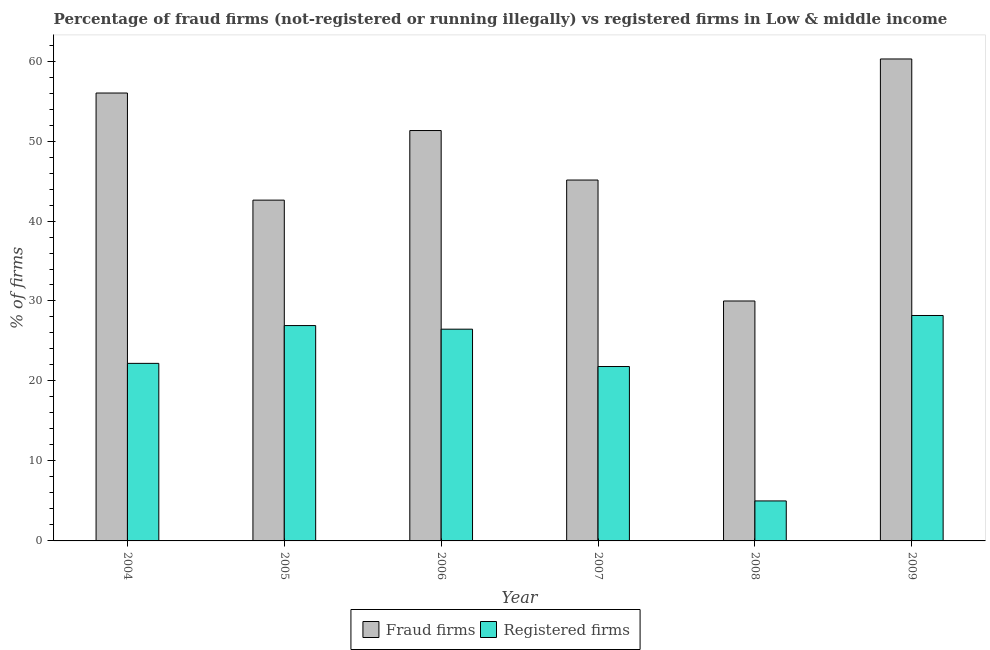How many groups of bars are there?
Provide a short and direct response. 6. How many bars are there on the 2nd tick from the left?
Provide a short and direct response. 2. How many bars are there on the 2nd tick from the right?
Keep it short and to the point. 2. What is the label of the 6th group of bars from the left?
Offer a terse response. 2009. What is the percentage of registered firms in 2005?
Offer a very short reply. 26.93. Across all years, what is the maximum percentage of registered firms?
Your answer should be compact. 28.19. Across all years, what is the minimum percentage of fraud firms?
Keep it short and to the point. 30. What is the total percentage of fraud firms in the graph?
Provide a short and direct response. 285.31. What is the difference between the percentage of registered firms in 2005 and that in 2009?
Ensure brevity in your answer.  -1.26. What is the difference between the percentage of registered firms in 2008 and the percentage of fraud firms in 2004?
Keep it short and to the point. -17.2. What is the average percentage of fraud firms per year?
Your answer should be very brief. 47.55. In the year 2005, what is the difference between the percentage of fraud firms and percentage of registered firms?
Make the answer very short. 0. What is the ratio of the percentage of registered firms in 2004 to that in 2005?
Provide a succinct answer. 0.82. Is the difference between the percentage of fraud firms in 2005 and 2009 greater than the difference between the percentage of registered firms in 2005 and 2009?
Make the answer very short. No. What is the difference between the highest and the second highest percentage of registered firms?
Offer a terse response. 1.26. What is the difference between the highest and the lowest percentage of fraud firms?
Your response must be concise. 30.26. What does the 1st bar from the left in 2008 represents?
Your answer should be very brief. Fraud firms. What does the 2nd bar from the right in 2008 represents?
Your answer should be very brief. Fraud firms. How many bars are there?
Make the answer very short. 12. Are all the bars in the graph horizontal?
Offer a very short reply. No. How many years are there in the graph?
Give a very brief answer. 6. What is the difference between two consecutive major ticks on the Y-axis?
Make the answer very short. 10. Are the values on the major ticks of Y-axis written in scientific E-notation?
Offer a terse response. No. Does the graph contain any zero values?
Keep it short and to the point. No. Where does the legend appear in the graph?
Your response must be concise. Bottom center. What is the title of the graph?
Ensure brevity in your answer.  Percentage of fraud firms (not-registered or running illegally) vs registered firms in Low & middle income. What is the label or title of the Y-axis?
Offer a terse response. % of firms. What is the % of firms of Fraud firms in 2004?
Keep it short and to the point. 56.01. What is the % of firms of Fraud firms in 2005?
Give a very brief answer. 42.61. What is the % of firms of Registered firms in 2005?
Ensure brevity in your answer.  26.93. What is the % of firms of Fraud firms in 2006?
Make the answer very short. 51.31. What is the % of firms of Registered firms in 2006?
Keep it short and to the point. 26.48. What is the % of firms of Fraud firms in 2007?
Ensure brevity in your answer.  45.12. What is the % of firms of Registered firms in 2007?
Your answer should be compact. 21.81. What is the % of firms in Fraud firms in 2008?
Provide a short and direct response. 30. What is the % of firms in Fraud firms in 2009?
Provide a short and direct response. 60.26. What is the % of firms in Registered firms in 2009?
Provide a succinct answer. 28.19. Across all years, what is the maximum % of firms of Fraud firms?
Provide a short and direct response. 60.26. Across all years, what is the maximum % of firms of Registered firms?
Offer a very short reply. 28.19. Across all years, what is the minimum % of firms in Registered firms?
Your answer should be very brief. 5. What is the total % of firms of Fraud firms in the graph?
Make the answer very short. 285.31. What is the total % of firms in Registered firms in the graph?
Your answer should be compact. 130.6. What is the difference between the % of firms of Fraud firms in 2004 and that in 2005?
Offer a terse response. 13.39. What is the difference between the % of firms of Registered firms in 2004 and that in 2005?
Keep it short and to the point. -4.73. What is the difference between the % of firms in Fraud firms in 2004 and that in 2006?
Keep it short and to the point. 4.69. What is the difference between the % of firms in Registered firms in 2004 and that in 2006?
Ensure brevity in your answer.  -4.28. What is the difference between the % of firms in Fraud firms in 2004 and that in 2007?
Ensure brevity in your answer.  10.88. What is the difference between the % of firms of Registered firms in 2004 and that in 2007?
Your answer should be compact. 0.39. What is the difference between the % of firms of Fraud firms in 2004 and that in 2008?
Ensure brevity in your answer.  26. What is the difference between the % of firms in Fraud firms in 2004 and that in 2009?
Make the answer very short. -4.26. What is the difference between the % of firms of Registered firms in 2004 and that in 2009?
Your answer should be compact. -5.99. What is the difference between the % of firms in Fraud firms in 2005 and that in 2006?
Offer a terse response. -8.7. What is the difference between the % of firms of Registered firms in 2005 and that in 2006?
Provide a succinct answer. 0.45. What is the difference between the % of firms of Fraud firms in 2005 and that in 2007?
Ensure brevity in your answer.  -2.51. What is the difference between the % of firms of Registered firms in 2005 and that in 2007?
Your answer should be compact. 5.12. What is the difference between the % of firms in Fraud firms in 2005 and that in 2008?
Provide a succinct answer. 12.61. What is the difference between the % of firms of Registered firms in 2005 and that in 2008?
Ensure brevity in your answer.  21.93. What is the difference between the % of firms in Fraud firms in 2005 and that in 2009?
Your response must be concise. -17.65. What is the difference between the % of firms of Registered firms in 2005 and that in 2009?
Your answer should be compact. -1.26. What is the difference between the % of firms in Fraud firms in 2006 and that in 2007?
Make the answer very short. 6.19. What is the difference between the % of firms in Registered firms in 2006 and that in 2007?
Provide a succinct answer. 4.67. What is the difference between the % of firms in Fraud firms in 2006 and that in 2008?
Ensure brevity in your answer.  21.31. What is the difference between the % of firms of Registered firms in 2006 and that in 2008?
Offer a terse response. 21.48. What is the difference between the % of firms of Fraud firms in 2006 and that in 2009?
Your answer should be very brief. -8.95. What is the difference between the % of firms of Registered firms in 2006 and that in 2009?
Provide a short and direct response. -1.71. What is the difference between the % of firms in Fraud firms in 2007 and that in 2008?
Your answer should be compact. 15.12. What is the difference between the % of firms of Registered firms in 2007 and that in 2008?
Make the answer very short. 16.81. What is the difference between the % of firms of Fraud firms in 2007 and that in 2009?
Provide a succinct answer. -15.14. What is the difference between the % of firms in Registered firms in 2007 and that in 2009?
Keep it short and to the point. -6.38. What is the difference between the % of firms of Fraud firms in 2008 and that in 2009?
Provide a succinct answer. -30.26. What is the difference between the % of firms in Registered firms in 2008 and that in 2009?
Your response must be concise. -23.19. What is the difference between the % of firms in Fraud firms in 2004 and the % of firms in Registered firms in 2005?
Provide a succinct answer. 29.08. What is the difference between the % of firms of Fraud firms in 2004 and the % of firms of Registered firms in 2006?
Make the answer very short. 29.53. What is the difference between the % of firms of Fraud firms in 2004 and the % of firms of Registered firms in 2007?
Ensure brevity in your answer.  34.2. What is the difference between the % of firms of Fraud firms in 2004 and the % of firms of Registered firms in 2008?
Your answer should be very brief. 51.01. What is the difference between the % of firms of Fraud firms in 2004 and the % of firms of Registered firms in 2009?
Keep it short and to the point. 27.82. What is the difference between the % of firms in Fraud firms in 2005 and the % of firms in Registered firms in 2006?
Offer a terse response. 16.13. What is the difference between the % of firms of Fraud firms in 2005 and the % of firms of Registered firms in 2007?
Your answer should be compact. 20.8. What is the difference between the % of firms of Fraud firms in 2005 and the % of firms of Registered firms in 2008?
Keep it short and to the point. 37.61. What is the difference between the % of firms of Fraud firms in 2005 and the % of firms of Registered firms in 2009?
Ensure brevity in your answer.  14.42. What is the difference between the % of firms in Fraud firms in 2006 and the % of firms in Registered firms in 2007?
Offer a terse response. 29.51. What is the difference between the % of firms of Fraud firms in 2006 and the % of firms of Registered firms in 2008?
Offer a terse response. 46.31. What is the difference between the % of firms in Fraud firms in 2006 and the % of firms in Registered firms in 2009?
Your response must be concise. 23.13. What is the difference between the % of firms in Fraud firms in 2007 and the % of firms in Registered firms in 2008?
Give a very brief answer. 40.12. What is the difference between the % of firms in Fraud firms in 2007 and the % of firms in Registered firms in 2009?
Ensure brevity in your answer.  16.94. What is the difference between the % of firms in Fraud firms in 2008 and the % of firms in Registered firms in 2009?
Give a very brief answer. 1.81. What is the average % of firms in Fraud firms per year?
Provide a succinct answer. 47.55. What is the average % of firms in Registered firms per year?
Provide a short and direct response. 21.77. In the year 2004, what is the difference between the % of firms of Fraud firms and % of firms of Registered firms?
Provide a short and direct response. 33.8. In the year 2005, what is the difference between the % of firms in Fraud firms and % of firms in Registered firms?
Offer a terse response. 15.68. In the year 2006, what is the difference between the % of firms in Fraud firms and % of firms in Registered firms?
Your response must be concise. 24.84. In the year 2007, what is the difference between the % of firms in Fraud firms and % of firms in Registered firms?
Provide a short and direct response. 23.32. In the year 2008, what is the difference between the % of firms of Fraud firms and % of firms of Registered firms?
Your answer should be very brief. 25. In the year 2009, what is the difference between the % of firms of Fraud firms and % of firms of Registered firms?
Your answer should be compact. 32.07. What is the ratio of the % of firms of Fraud firms in 2004 to that in 2005?
Provide a short and direct response. 1.31. What is the ratio of the % of firms of Registered firms in 2004 to that in 2005?
Give a very brief answer. 0.82. What is the ratio of the % of firms in Fraud firms in 2004 to that in 2006?
Make the answer very short. 1.09. What is the ratio of the % of firms in Registered firms in 2004 to that in 2006?
Your answer should be compact. 0.84. What is the ratio of the % of firms in Fraud firms in 2004 to that in 2007?
Ensure brevity in your answer.  1.24. What is the ratio of the % of firms in Registered firms in 2004 to that in 2007?
Your answer should be compact. 1.02. What is the ratio of the % of firms of Fraud firms in 2004 to that in 2008?
Offer a terse response. 1.87. What is the ratio of the % of firms in Registered firms in 2004 to that in 2008?
Provide a short and direct response. 4.44. What is the ratio of the % of firms of Fraud firms in 2004 to that in 2009?
Your answer should be very brief. 0.93. What is the ratio of the % of firms of Registered firms in 2004 to that in 2009?
Your answer should be very brief. 0.79. What is the ratio of the % of firms of Fraud firms in 2005 to that in 2006?
Keep it short and to the point. 0.83. What is the ratio of the % of firms in Registered firms in 2005 to that in 2006?
Provide a succinct answer. 1.02. What is the ratio of the % of firms of Fraud firms in 2005 to that in 2007?
Provide a short and direct response. 0.94. What is the ratio of the % of firms in Registered firms in 2005 to that in 2007?
Provide a short and direct response. 1.23. What is the ratio of the % of firms of Fraud firms in 2005 to that in 2008?
Make the answer very short. 1.42. What is the ratio of the % of firms of Registered firms in 2005 to that in 2008?
Offer a terse response. 5.39. What is the ratio of the % of firms of Fraud firms in 2005 to that in 2009?
Ensure brevity in your answer.  0.71. What is the ratio of the % of firms of Registered firms in 2005 to that in 2009?
Give a very brief answer. 0.96. What is the ratio of the % of firms in Fraud firms in 2006 to that in 2007?
Offer a terse response. 1.14. What is the ratio of the % of firms in Registered firms in 2006 to that in 2007?
Keep it short and to the point. 1.21. What is the ratio of the % of firms of Fraud firms in 2006 to that in 2008?
Your answer should be compact. 1.71. What is the ratio of the % of firms in Registered firms in 2006 to that in 2008?
Make the answer very short. 5.3. What is the ratio of the % of firms of Fraud firms in 2006 to that in 2009?
Offer a terse response. 0.85. What is the ratio of the % of firms of Registered firms in 2006 to that in 2009?
Provide a succinct answer. 0.94. What is the ratio of the % of firms in Fraud firms in 2007 to that in 2008?
Your answer should be very brief. 1.5. What is the ratio of the % of firms in Registered firms in 2007 to that in 2008?
Offer a very short reply. 4.36. What is the ratio of the % of firms in Fraud firms in 2007 to that in 2009?
Your answer should be very brief. 0.75. What is the ratio of the % of firms of Registered firms in 2007 to that in 2009?
Offer a terse response. 0.77. What is the ratio of the % of firms of Fraud firms in 2008 to that in 2009?
Provide a short and direct response. 0.5. What is the ratio of the % of firms of Registered firms in 2008 to that in 2009?
Keep it short and to the point. 0.18. What is the difference between the highest and the second highest % of firms in Fraud firms?
Your answer should be very brief. 4.26. What is the difference between the highest and the second highest % of firms in Registered firms?
Offer a very short reply. 1.26. What is the difference between the highest and the lowest % of firms in Fraud firms?
Keep it short and to the point. 30.26. What is the difference between the highest and the lowest % of firms in Registered firms?
Make the answer very short. 23.19. 